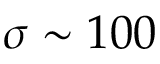Convert formula to latex. <formula><loc_0><loc_0><loc_500><loc_500>\sigma \sim 1 0 0</formula> 